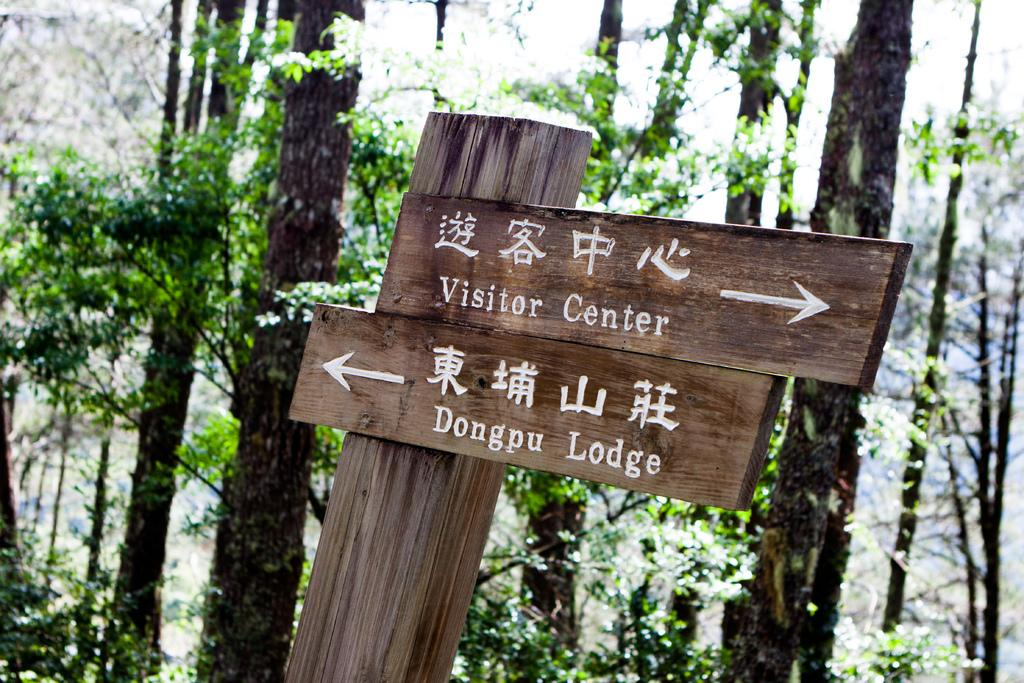What type of vegetation can be seen in the image? There are trees in the image. What material is the board in the image made of? The wooden board in the image is made of wood. What type of button can be seen on the floor in the image? There is no button present on the floor in the image. What type of milk is being poured from a container in the image? There is no milk or container present in the image. 